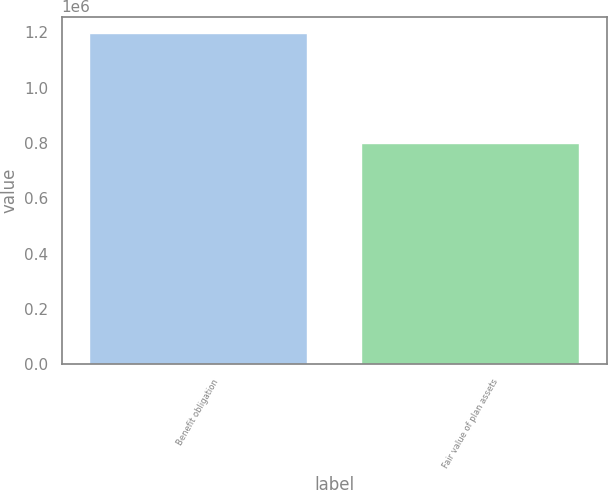Convert chart to OTSL. <chart><loc_0><loc_0><loc_500><loc_500><bar_chart><fcel>Benefit obligation<fcel>Fair value of plan assets<nl><fcel>1.19719e+06<fcel>799191<nl></chart> 